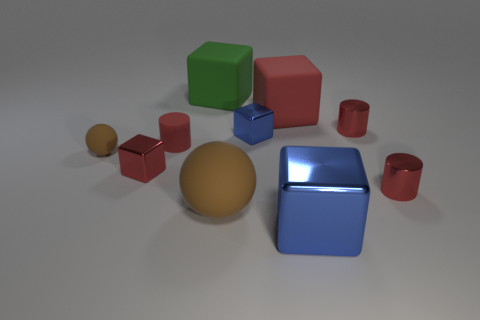What number of objects are green objects or red objects that are in front of the rubber cylinder?
Offer a terse response. 3. There is a blue block that is the same size as the green block; what material is it?
Give a very brief answer. Metal. Does the tiny brown object have the same material as the big red thing?
Your answer should be compact. Yes. There is a metal cube that is both to the right of the red metal cube and behind the big blue metal block; what is its color?
Give a very brief answer. Blue. There is a cylinder that is on the left side of the large blue cube; does it have the same color as the large metal cube?
Provide a succinct answer. No. There is a metallic thing that is the same size as the green matte block; what shape is it?
Give a very brief answer. Cube. What number of other things are the same color as the rubber cylinder?
Your answer should be compact. 4. How many other objects are there of the same material as the large green block?
Provide a succinct answer. 4. There is a red rubber cylinder; does it have the same size as the blue thing that is in front of the tiny rubber sphere?
Your answer should be very brief. No. The big sphere is what color?
Provide a short and direct response. Brown. 